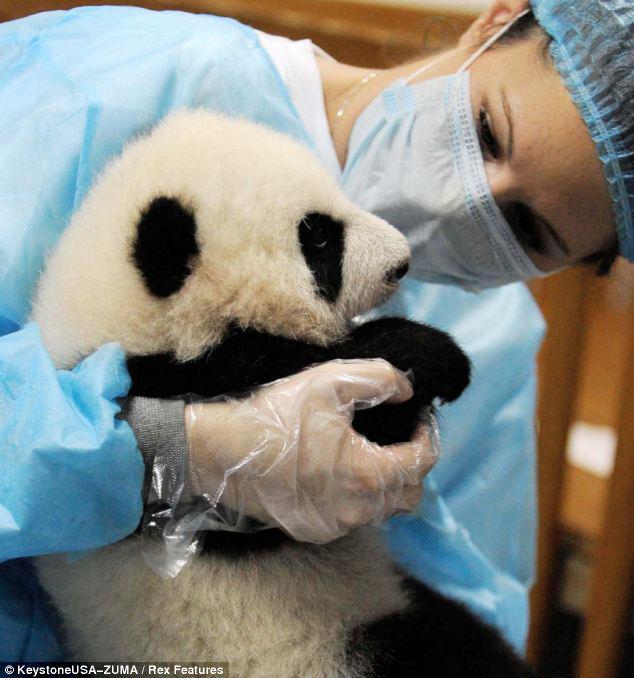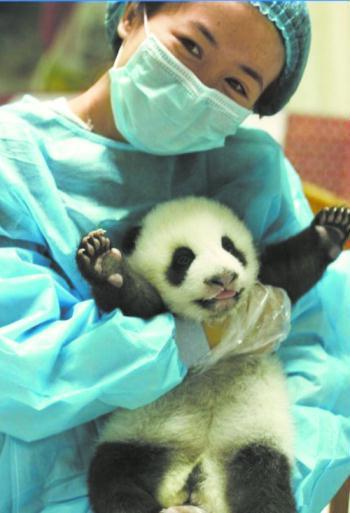The first image is the image on the left, the second image is the image on the right. Given the left and right images, does the statement "One of the pandas is being fed a bottle by a person wearing a protective blue garment." hold true? Answer yes or no. No. The first image is the image on the left, the second image is the image on the right. For the images displayed, is the sentence "In one of the images, there are least two people interacting with a panda bear." factually correct? Answer yes or no. No. 